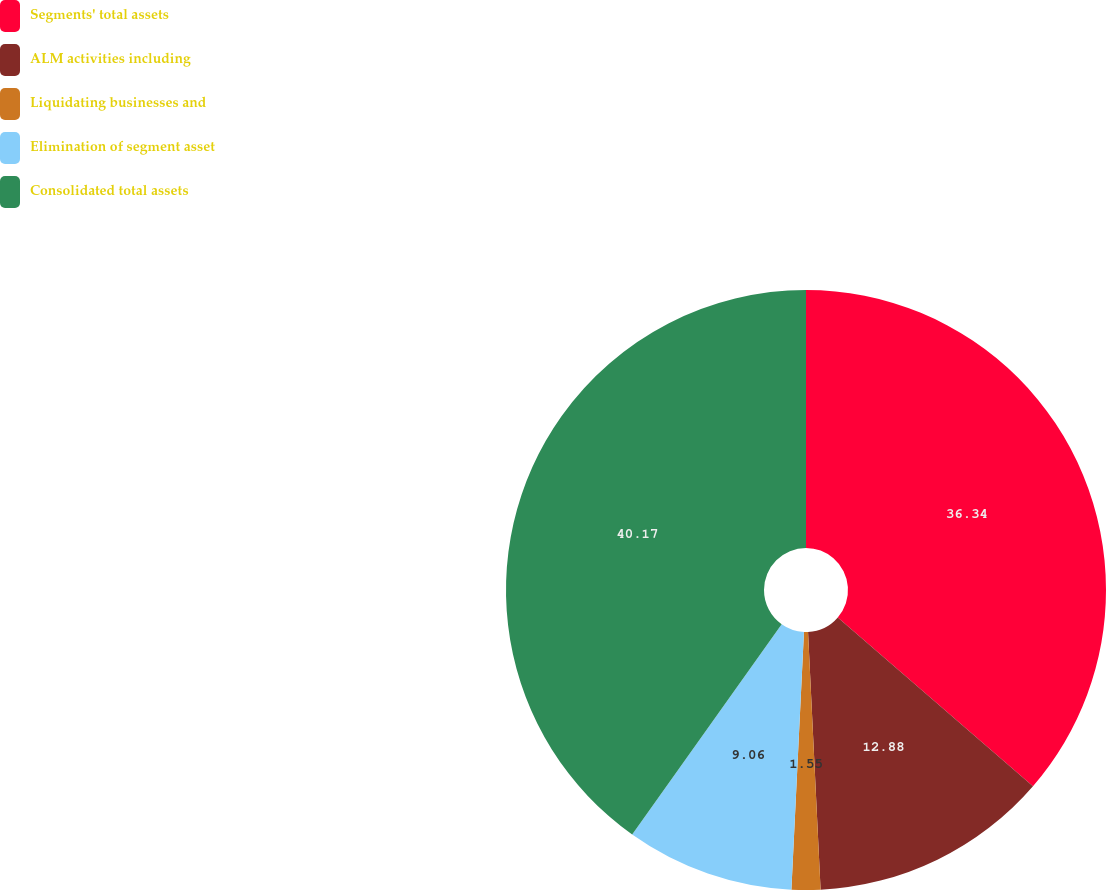Convert chart to OTSL. <chart><loc_0><loc_0><loc_500><loc_500><pie_chart><fcel>Segments' total assets<fcel>ALM activities including<fcel>Liquidating businesses and<fcel>Elimination of segment asset<fcel>Consolidated total assets<nl><fcel>36.34%<fcel>12.88%<fcel>1.55%<fcel>9.06%<fcel>40.16%<nl></chart> 